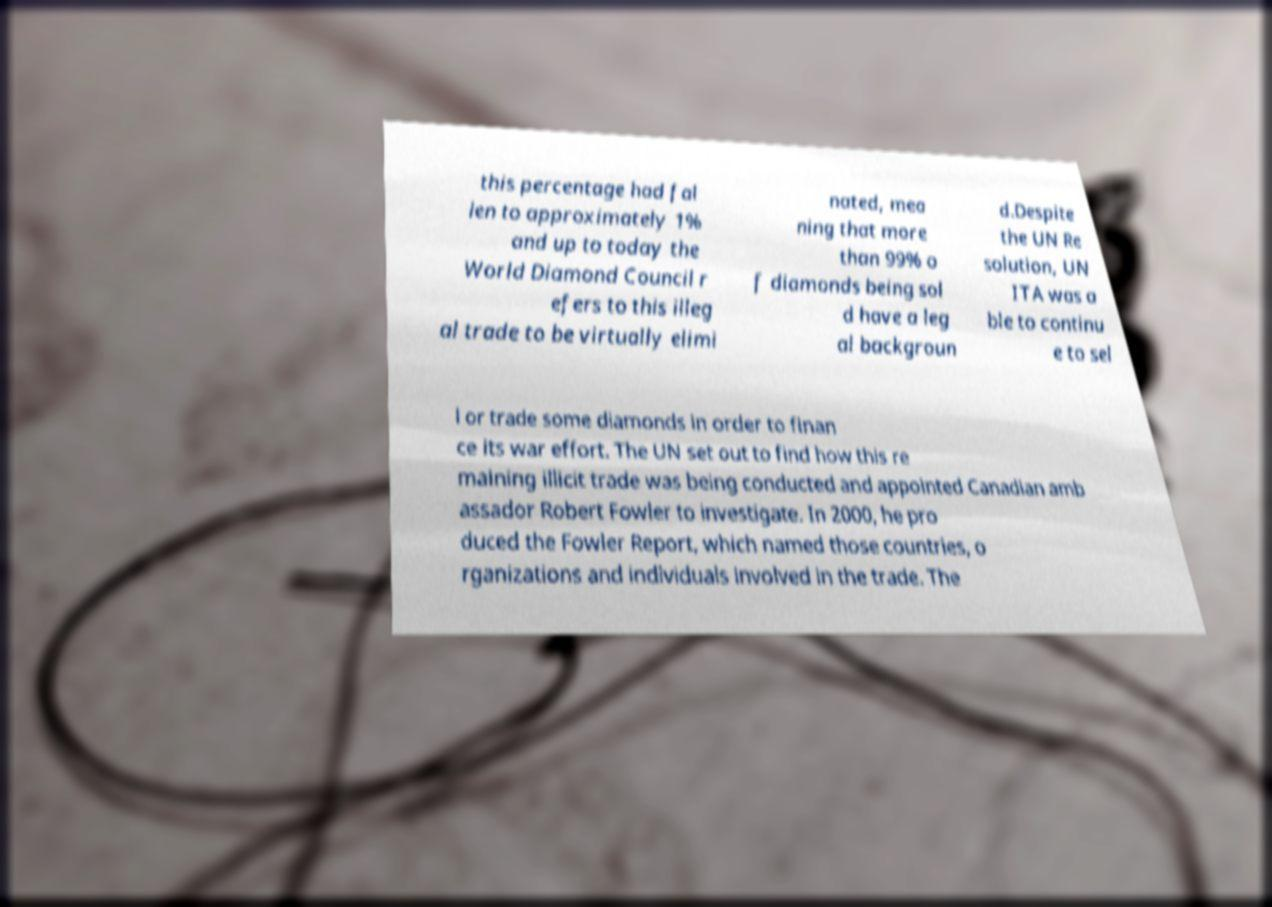Could you assist in decoding the text presented in this image and type it out clearly? this percentage had fal len to approximately 1% and up to today the World Diamond Council r efers to this illeg al trade to be virtually elimi nated, mea ning that more than 99% o f diamonds being sol d have a leg al backgroun d.Despite the UN Re solution, UN ITA was a ble to continu e to sel l or trade some diamonds in order to finan ce its war effort. The UN set out to find how this re maining illicit trade was being conducted and appointed Canadian amb assador Robert Fowler to investigate. In 2000, he pro duced the Fowler Report, which named those countries, o rganizations and individuals involved in the trade. The 